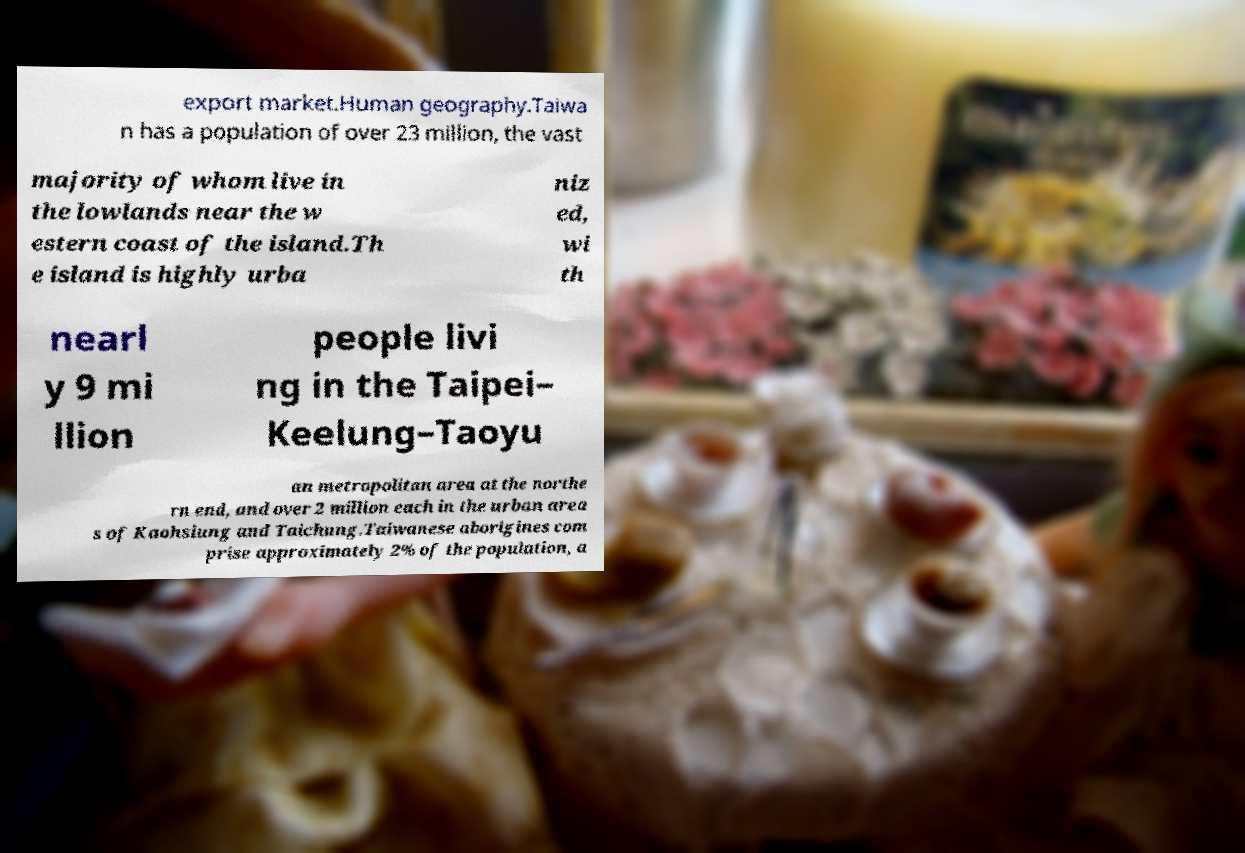For documentation purposes, I need the text within this image transcribed. Could you provide that? export market.Human geography.Taiwa n has a population of over 23 million, the vast majority of whom live in the lowlands near the w estern coast of the island.Th e island is highly urba niz ed, wi th nearl y 9 mi llion people livi ng in the Taipei– Keelung–Taoyu an metropolitan area at the northe rn end, and over 2 million each in the urban area s of Kaohsiung and Taichung.Taiwanese aborigines com prise approximately 2% of the population, a 